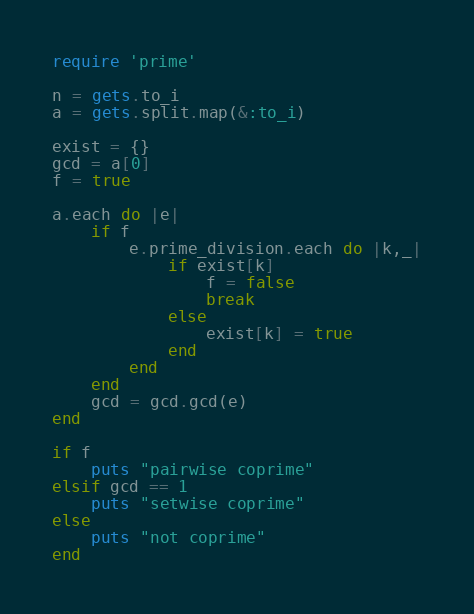<code> <loc_0><loc_0><loc_500><loc_500><_Ruby_>require 'prime'

n = gets.to_i
a = gets.split.map(&:to_i)

exist = {}
gcd = a[0]
f = true

a.each do |e|
    if f
        e.prime_division.each do |k,_|
            if exist[k]
                f = false
                break
            else
                exist[k] = true
            end
        end
    end
    gcd = gcd.gcd(e)
end

if f
    puts "pairwise coprime"
elsif gcd == 1
    puts "setwise coprime"
else
    puts "not coprime"
end</code> 